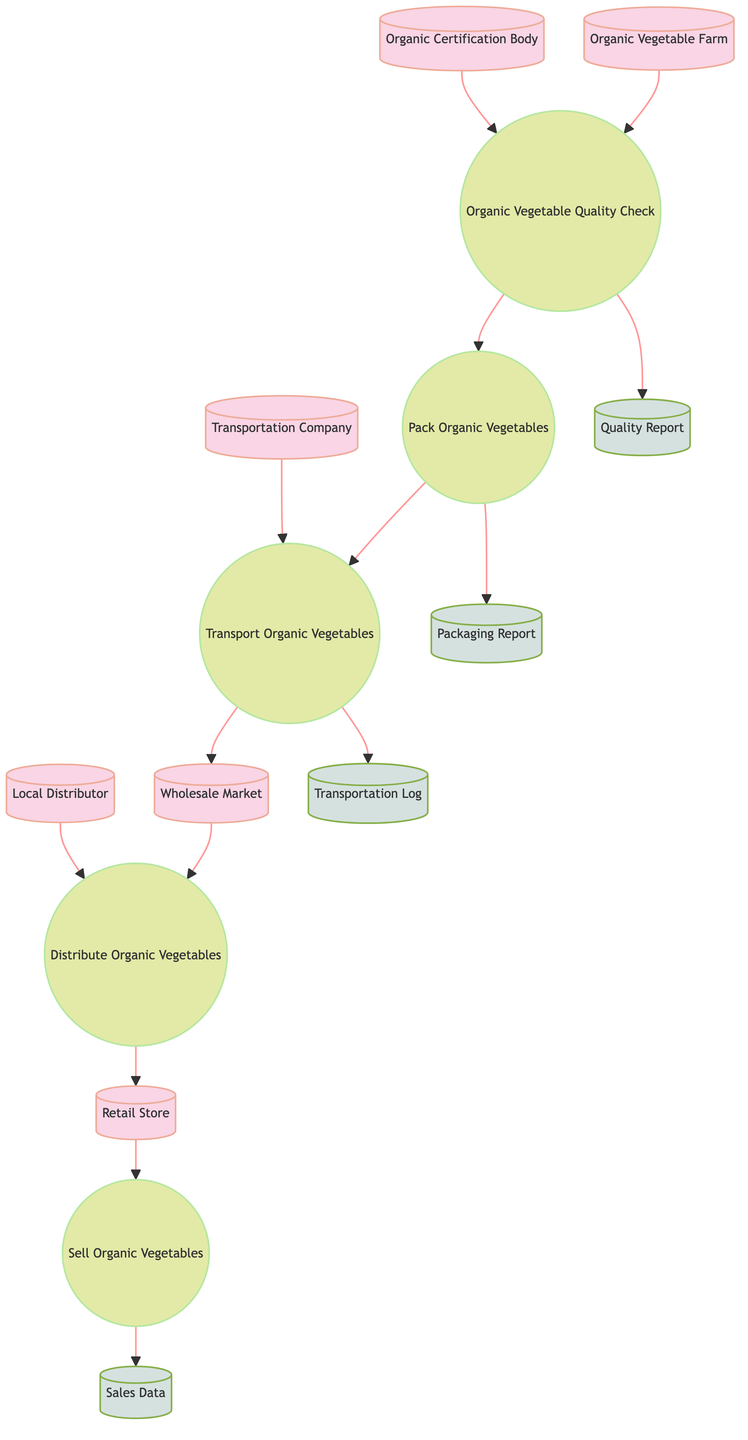What is the first external entity in the diagram? The first external entity listed in the diagram is the "Organic Vegetable Farm," which has the ID of 1. This can be easily identified as it is the first item listed under the "elements" section.
Answer: Organic Vegetable Farm How many processes are there in the diagram? The diagram includes five processes, namely: Organic Vegetable Quality Check, Pack Organic Vegetables, Transport Organic Vegetables, Distribute Organic Vegetables, and Sell Organic Vegetables. Counting these processes shows that there are five total.
Answer: 5 What type of relationship exists between the Organic Certification Body and the Organic Vegetable Quality Check? The Organic Certification Body sends information to the Organic Vegetable Quality Check, which indicates that it is an input to the process; thus, the relationship is an input-output type where the certification body provides necessary information for the quality check.
Answer: Input What is the final data store in the flow of the diagram? The last data store in the flow is "Sales Data," which is the final output collected after the Sell Organic Vegetables process is completed. Tracing the arrows leads to identifying it as the endpoint for sales information.
Answer: Sales Data Which process directly receives input from the Transport Organic Vegetables? The process that directly receives input from the Transport Organic Vegetables is the Distribute Organic Vegetables. This is evident from the directed arrow flow from the Transport Organic Vegetables process to the Distribute Organic Vegetables process.
Answer: Distribute Organic Vegetables How many external entities are involved in the supply chain? The diagram comprises six external entities: Organic Vegetable Farm, Organic Certification Body, Transportation Company, Wholesale Market, Local Distributor, and Retail Store. Counting these entities shows that there are six total involved in the supply chain.
Answer: 6 What data store receives information from the Pack Organic Vegetables process? The data store that receives information from the Pack Organic Vegetables process is the Packaging Report. This is demonstrated by the arrow that indicates a flow of information from the Pack Organic Vegetables process to the Packaging Report.
Answer: Packaging Report Which process comes before the Sell Organic Vegetables process? The process that precedes the Sell Organic Vegetables process is the Distribute Organic Vegetables process. The flow chart outlines a clear sequence, showing the order in which these processes occur.
Answer: Distribute Organic Vegetables 